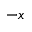Convert formula to latex. <formula><loc_0><loc_0><loc_500><loc_500>- x</formula> 